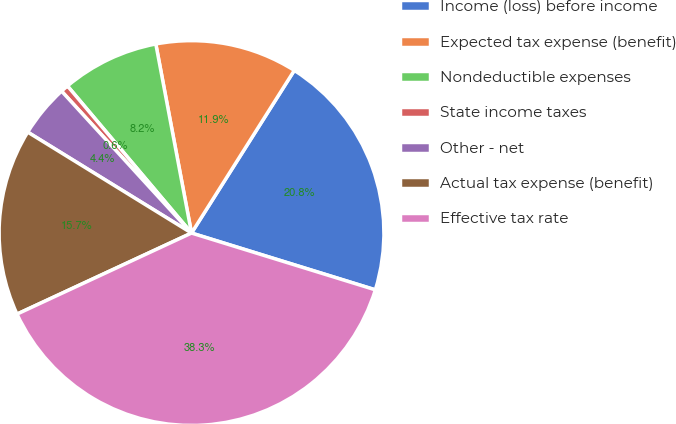<chart> <loc_0><loc_0><loc_500><loc_500><pie_chart><fcel>Income (loss) before income<fcel>Expected tax expense (benefit)<fcel>Nondeductible expenses<fcel>State income taxes<fcel>Other - net<fcel>Actual tax expense (benefit)<fcel>Effective tax rate<nl><fcel>20.8%<fcel>11.94%<fcel>8.18%<fcel>0.65%<fcel>4.41%<fcel>15.71%<fcel>38.31%<nl></chart> 